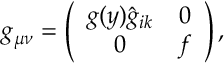Convert formula to latex. <formula><loc_0><loc_0><loc_500><loc_500>g _ { \mu \nu } = \left ( \begin{array} { c c } { { g ( y ) \hat { g } _ { i k } } } & { 0 } \\ { 0 } & { f } \end{array} \right ) ,</formula> 